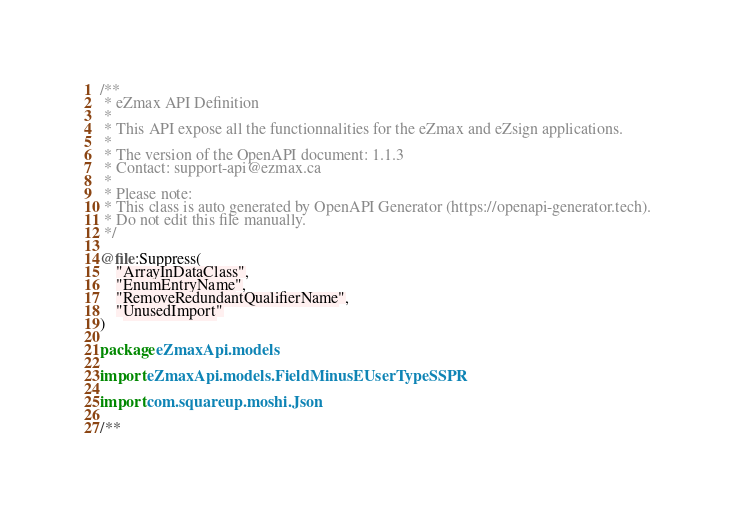Convert code to text. <code><loc_0><loc_0><loc_500><loc_500><_Kotlin_>/**
 * eZmax API Definition
 *
 * This API expose all the functionnalities for the eZmax and eZsign applications.
 *
 * The version of the OpenAPI document: 1.1.3
 * Contact: support-api@ezmax.ca
 *
 * Please note:
 * This class is auto generated by OpenAPI Generator (https://openapi-generator.tech).
 * Do not edit this file manually.
 */

@file:Suppress(
    "ArrayInDataClass",
    "EnumEntryName",
    "RemoveRedundantQualifierName",
    "UnusedImport"
)

package eZmaxApi.models

import eZmaxApi.models.FieldMinusEUserTypeSSPR

import com.squareup.moshi.Json

/**</code> 